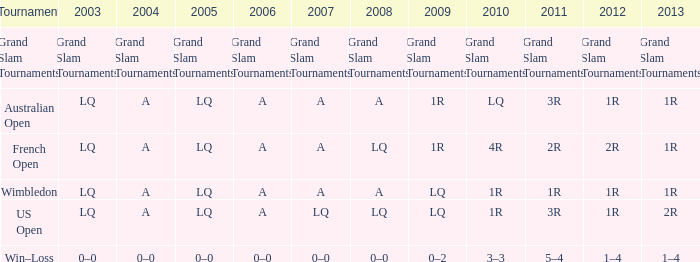When does 1r stand for the year 2011? A. 